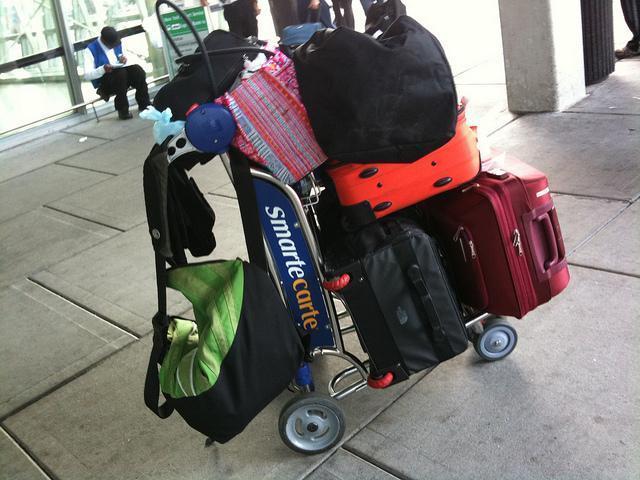How many handbags are there?
Give a very brief answer. 1. How many backpacks are in the photo?
Give a very brief answer. 2. How many suitcases are in the photo?
Give a very brief answer. 3. How many elephants can you see it's trunk?
Give a very brief answer. 0. 